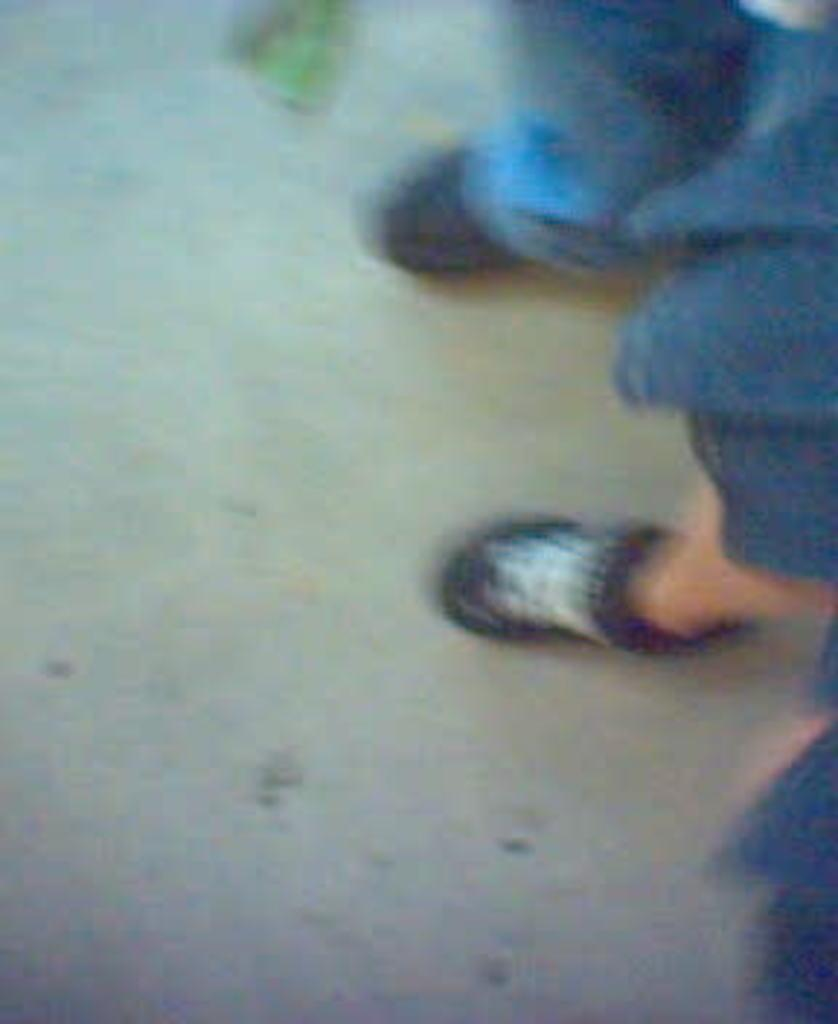What is the overall quality of the image? The image is blurry. What can be seen in the image despite its blurriness? Two legs of two different persons are visible in the image. What type of lunchroom is depicted in the image? There is no lunchroom present in the image; it only shows two legs of two different persons. How does the jar of love fit into the image? There is no jar of love present in the image; it only shows two legs of two different persons. 